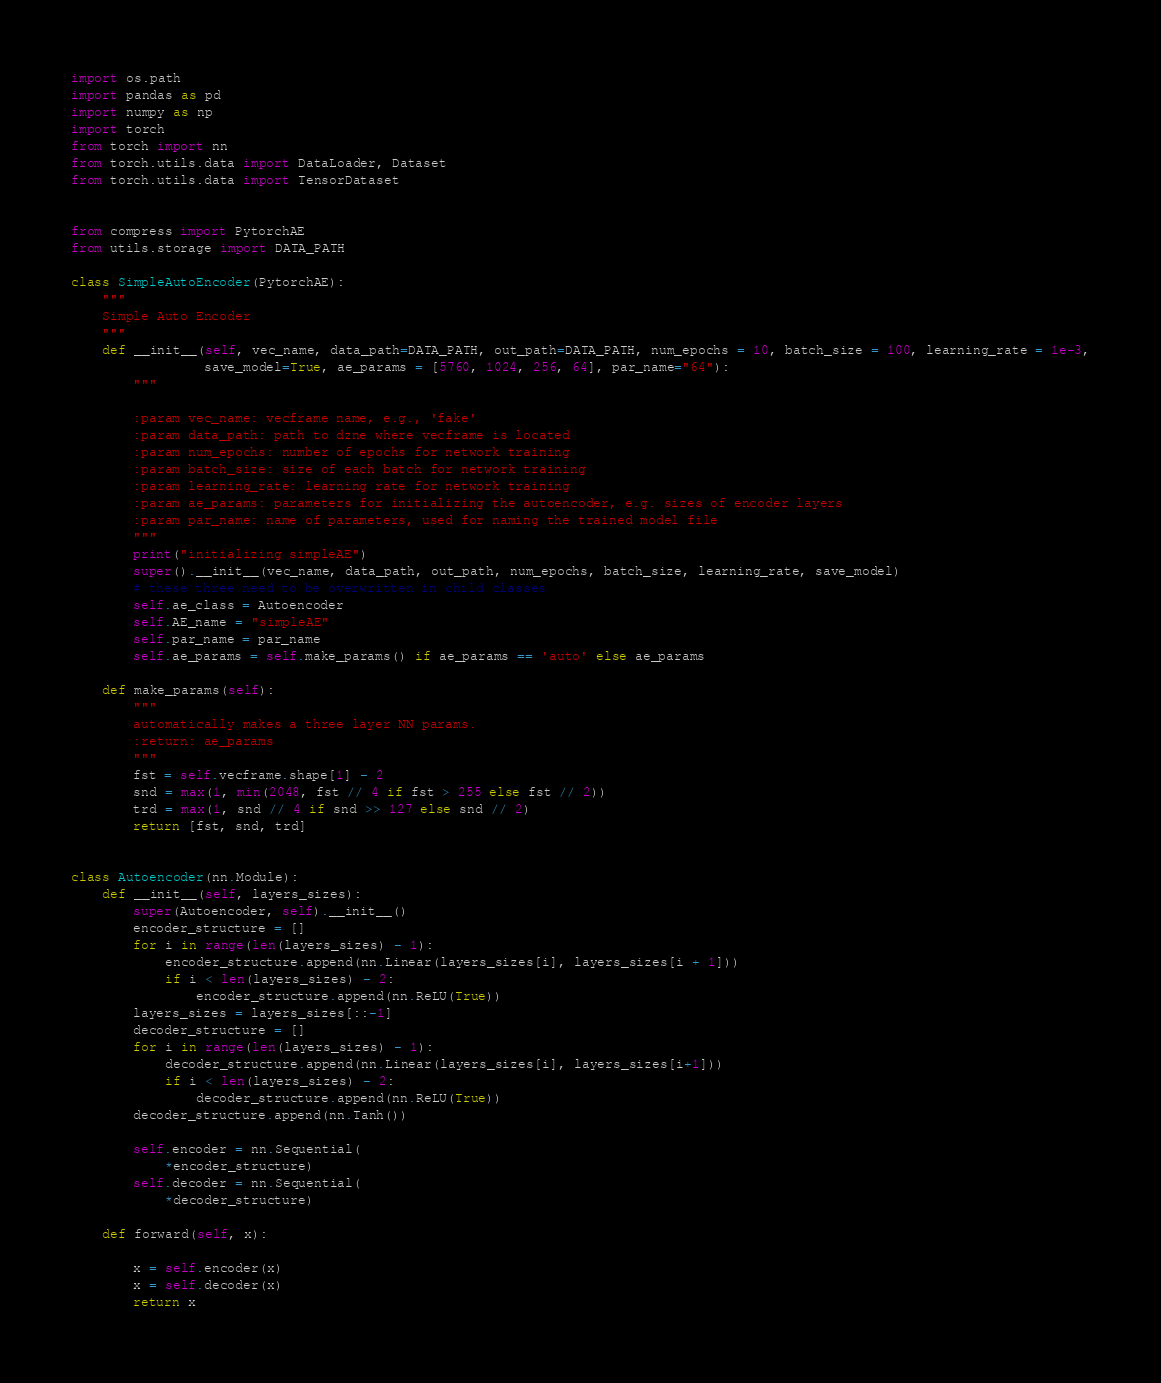Convert code to text. <code><loc_0><loc_0><loc_500><loc_500><_Python_>import os.path
import pandas as pd
import numpy as np
import torch
from torch import nn
from torch.utils.data import DataLoader, Dataset
from torch.utils.data import TensorDataset


from compress import PytorchAE
from utils.storage import DATA_PATH

class SimpleAutoEncoder(PytorchAE):
    """
    Simple Auto Encoder
    """
    def __init__(self, vec_name, data_path=DATA_PATH, out_path=DATA_PATH, num_epochs = 10, batch_size = 100, learning_rate = 1e-3,
                 save_model=True, ae_params = [5760, 1024, 256, 64], par_name="64"):
        """

        :param vec_name: vecframe name, e.g., 'fake'
        :param data_path: path to dzne where vecframe is located
        :param num_epochs: number of epochs for network training
        :param batch_size: size of each batch for network training
        :param learning_rate: learning rate for network training
        :param ae_params: parameters for initializing the autoencoder, e.g. sizes of encoder layers
        :param par_name: name of parameters, used for naming the trained model file
        """
        print("initializing simpleAE")
        super().__init__(vec_name, data_path, out_path, num_epochs, batch_size, learning_rate, save_model)
        # these three need to be overwritten in child classes
        self.ae_class = Autoencoder
        self.AE_name = "simpleAE"
        self.par_name = par_name
        self.ae_params = self.make_params() if ae_params == 'auto' else ae_params

    def make_params(self):
        """
        automatically makes a three layer NN params.
        :return: ae_params
        """
        fst = self.vecframe.shape[1] - 2
        snd = max(1, min(2048, fst // 4 if fst > 255 else fst // 2))
        trd = max(1, snd // 4 if snd >> 127 else snd // 2)
        return [fst, snd, trd]


class Autoencoder(nn.Module):
    def __init__(self, layers_sizes):
        super(Autoencoder, self).__init__()
        encoder_structure = []
        for i in range(len(layers_sizes) - 1):
            encoder_structure.append(nn.Linear(layers_sizes[i], layers_sizes[i + 1]))
            if i < len(layers_sizes) - 2:
                encoder_structure.append(nn.ReLU(True))
        layers_sizes = layers_sizes[::-1]
        decoder_structure = []
        for i in range(len(layers_sizes) - 1):
            decoder_structure.append(nn.Linear(layers_sizes[i], layers_sizes[i+1]))
            if i < len(layers_sizes) - 2:
                decoder_structure.append(nn.ReLU(True))
        decoder_structure.append(nn.Tanh())

        self.encoder = nn.Sequential(
            *encoder_structure)
        self.decoder = nn.Sequential(
            *decoder_structure)

    def forward(self, x):

        x = self.encoder(x)
        x = self.decoder(x)
        return x
</code> 